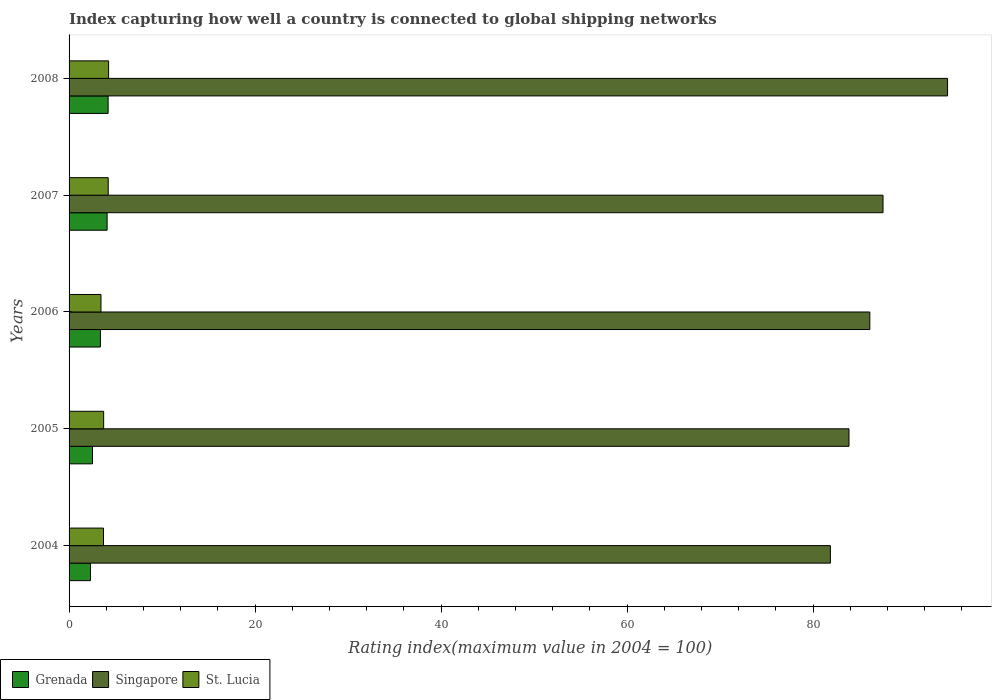How many different coloured bars are there?
Provide a short and direct response. 3. Are the number of bars on each tick of the Y-axis equal?
Keep it short and to the point. Yes. How many bars are there on the 3rd tick from the top?
Offer a terse response. 3. What is the label of the 1st group of bars from the top?
Give a very brief answer. 2008. In how many cases, is the number of bars for a given year not equal to the number of legend labels?
Your answer should be compact. 0. What is the rating index in St. Lucia in 2007?
Give a very brief answer. 4.21. Across all years, what is the maximum rating index in St. Lucia?
Give a very brief answer. 4.25. In which year was the rating index in Grenada minimum?
Ensure brevity in your answer.  2004. What is the total rating index in St. Lucia in the graph?
Your response must be concise. 19.31. What is the difference between the rating index in St. Lucia in 2006 and that in 2007?
Make the answer very short. -0.78. What is the difference between the rating index in St. Lucia in 2006 and the rating index in Singapore in 2005?
Offer a terse response. -80.44. What is the average rating index in Singapore per year?
Your response must be concise. 86.77. In the year 2006, what is the difference between the rating index in St. Lucia and rating index in Grenada?
Offer a terse response. 0.06. In how many years, is the rating index in Singapore greater than 64 ?
Provide a short and direct response. 5. What is the ratio of the rating index in Singapore in 2005 to that in 2008?
Your answer should be very brief. 0.89. Is the rating index in St. Lucia in 2005 less than that in 2007?
Provide a succinct answer. Yes. What is the difference between the highest and the second highest rating index in Singapore?
Provide a short and direct response. 6.94. What is the difference between the highest and the lowest rating index in Grenada?
Ensure brevity in your answer.  1.9. What does the 1st bar from the top in 2006 represents?
Your answer should be very brief. St. Lucia. What does the 3rd bar from the bottom in 2005 represents?
Provide a succinct answer. St. Lucia. Is it the case that in every year, the sum of the rating index in St. Lucia and rating index in Grenada is greater than the rating index in Singapore?
Offer a terse response. No. How many bars are there?
Keep it short and to the point. 15. Are all the bars in the graph horizontal?
Keep it short and to the point. Yes. How many years are there in the graph?
Ensure brevity in your answer.  5. Are the values on the major ticks of X-axis written in scientific E-notation?
Offer a very short reply. No. Does the graph contain any zero values?
Ensure brevity in your answer.  No. Where does the legend appear in the graph?
Ensure brevity in your answer.  Bottom left. How many legend labels are there?
Your response must be concise. 3. What is the title of the graph?
Your response must be concise. Index capturing how well a country is connected to global shipping networks. Does "Colombia" appear as one of the legend labels in the graph?
Your answer should be compact. No. What is the label or title of the X-axis?
Your answer should be very brief. Rating index(maximum value in 2004 = 100). What is the Rating index(maximum value in 2004 = 100) of Singapore in 2004?
Your response must be concise. 81.87. What is the Rating index(maximum value in 2004 = 100) of St. Lucia in 2004?
Your response must be concise. 3.7. What is the Rating index(maximum value in 2004 = 100) of Grenada in 2005?
Keep it short and to the point. 2.52. What is the Rating index(maximum value in 2004 = 100) in Singapore in 2005?
Offer a very short reply. 83.87. What is the Rating index(maximum value in 2004 = 100) of St. Lucia in 2005?
Provide a succinct answer. 3.72. What is the Rating index(maximum value in 2004 = 100) in Grenada in 2006?
Your response must be concise. 3.37. What is the Rating index(maximum value in 2004 = 100) in Singapore in 2006?
Provide a short and direct response. 86.11. What is the Rating index(maximum value in 2004 = 100) of St. Lucia in 2006?
Your answer should be compact. 3.43. What is the Rating index(maximum value in 2004 = 100) of Grenada in 2007?
Offer a very short reply. 4.09. What is the Rating index(maximum value in 2004 = 100) of Singapore in 2007?
Your answer should be very brief. 87.53. What is the Rating index(maximum value in 2004 = 100) in St. Lucia in 2007?
Make the answer very short. 4.21. What is the Rating index(maximum value in 2004 = 100) in Singapore in 2008?
Your response must be concise. 94.47. What is the Rating index(maximum value in 2004 = 100) of St. Lucia in 2008?
Ensure brevity in your answer.  4.25. Across all years, what is the maximum Rating index(maximum value in 2004 = 100) of Singapore?
Keep it short and to the point. 94.47. Across all years, what is the maximum Rating index(maximum value in 2004 = 100) in St. Lucia?
Give a very brief answer. 4.25. Across all years, what is the minimum Rating index(maximum value in 2004 = 100) of Singapore?
Your response must be concise. 81.87. Across all years, what is the minimum Rating index(maximum value in 2004 = 100) in St. Lucia?
Offer a terse response. 3.43. What is the total Rating index(maximum value in 2004 = 100) in Grenada in the graph?
Provide a short and direct response. 16.48. What is the total Rating index(maximum value in 2004 = 100) in Singapore in the graph?
Keep it short and to the point. 433.85. What is the total Rating index(maximum value in 2004 = 100) in St. Lucia in the graph?
Provide a succinct answer. 19.31. What is the difference between the Rating index(maximum value in 2004 = 100) of Grenada in 2004 and that in 2005?
Give a very brief answer. -0.22. What is the difference between the Rating index(maximum value in 2004 = 100) of St. Lucia in 2004 and that in 2005?
Make the answer very short. -0.02. What is the difference between the Rating index(maximum value in 2004 = 100) of Grenada in 2004 and that in 2006?
Offer a terse response. -1.07. What is the difference between the Rating index(maximum value in 2004 = 100) of Singapore in 2004 and that in 2006?
Provide a succinct answer. -4.24. What is the difference between the Rating index(maximum value in 2004 = 100) of St. Lucia in 2004 and that in 2006?
Ensure brevity in your answer.  0.27. What is the difference between the Rating index(maximum value in 2004 = 100) in Grenada in 2004 and that in 2007?
Keep it short and to the point. -1.79. What is the difference between the Rating index(maximum value in 2004 = 100) in Singapore in 2004 and that in 2007?
Provide a short and direct response. -5.66. What is the difference between the Rating index(maximum value in 2004 = 100) in St. Lucia in 2004 and that in 2007?
Your answer should be compact. -0.51. What is the difference between the Rating index(maximum value in 2004 = 100) in Singapore in 2004 and that in 2008?
Keep it short and to the point. -12.6. What is the difference between the Rating index(maximum value in 2004 = 100) of St. Lucia in 2004 and that in 2008?
Provide a succinct answer. -0.55. What is the difference between the Rating index(maximum value in 2004 = 100) in Grenada in 2005 and that in 2006?
Your response must be concise. -0.85. What is the difference between the Rating index(maximum value in 2004 = 100) of Singapore in 2005 and that in 2006?
Ensure brevity in your answer.  -2.24. What is the difference between the Rating index(maximum value in 2004 = 100) of St. Lucia in 2005 and that in 2006?
Offer a very short reply. 0.29. What is the difference between the Rating index(maximum value in 2004 = 100) in Grenada in 2005 and that in 2007?
Make the answer very short. -1.57. What is the difference between the Rating index(maximum value in 2004 = 100) in Singapore in 2005 and that in 2007?
Ensure brevity in your answer.  -3.66. What is the difference between the Rating index(maximum value in 2004 = 100) in St. Lucia in 2005 and that in 2007?
Provide a succinct answer. -0.49. What is the difference between the Rating index(maximum value in 2004 = 100) in Grenada in 2005 and that in 2008?
Your answer should be very brief. -1.68. What is the difference between the Rating index(maximum value in 2004 = 100) of St. Lucia in 2005 and that in 2008?
Offer a very short reply. -0.53. What is the difference between the Rating index(maximum value in 2004 = 100) of Grenada in 2006 and that in 2007?
Make the answer very short. -0.72. What is the difference between the Rating index(maximum value in 2004 = 100) in Singapore in 2006 and that in 2007?
Ensure brevity in your answer.  -1.42. What is the difference between the Rating index(maximum value in 2004 = 100) of St. Lucia in 2006 and that in 2007?
Your response must be concise. -0.78. What is the difference between the Rating index(maximum value in 2004 = 100) of Grenada in 2006 and that in 2008?
Ensure brevity in your answer.  -0.83. What is the difference between the Rating index(maximum value in 2004 = 100) of Singapore in 2006 and that in 2008?
Offer a very short reply. -8.36. What is the difference between the Rating index(maximum value in 2004 = 100) in St. Lucia in 2006 and that in 2008?
Your answer should be very brief. -0.82. What is the difference between the Rating index(maximum value in 2004 = 100) of Grenada in 2007 and that in 2008?
Offer a very short reply. -0.11. What is the difference between the Rating index(maximum value in 2004 = 100) of Singapore in 2007 and that in 2008?
Offer a very short reply. -6.94. What is the difference between the Rating index(maximum value in 2004 = 100) of St. Lucia in 2007 and that in 2008?
Offer a very short reply. -0.04. What is the difference between the Rating index(maximum value in 2004 = 100) of Grenada in 2004 and the Rating index(maximum value in 2004 = 100) of Singapore in 2005?
Your answer should be compact. -81.57. What is the difference between the Rating index(maximum value in 2004 = 100) in Grenada in 2004 and the Rating index(maximum value in 2004 = 100) in St. Lucia in 2005?
Offer a very short reply. -1.42. What is the difference between the Rating index(maximum value in 2004 = 100) of Singapore in 2004 and the Rating index(maximum value in 2004 = 100) of St. Lucia in 2005?
Offer a very short reply. 78.15. What is the difference between the Rating index(maximum value in 2004 = 100) of Grenada in 2004 and the Rating index(maximum value in 2004 = 100) of Singapore in 2006?
Provide a short and direct response. -83.81. What is the difference between the Rating index(maximum value in 2004 = 100) of Grenada in 2004 and the Rating index(maximum value in 2004 = 100) of St. Lucia in 2006?
Keep it short and to the point. -1.13. What is the difference between the Rating index(maximum value in 2004 = 100) in Singapore in 2004 and the Rating index(maximum value in 2004 = 100) in St. Lucia in 2006?
Keep it short and to the point. 78.44. What is the difference between the Rating index(maximum value in 2004 = 100) in Grenada in 2004 and the Rating index(maximum value in 2004 = 100) in Singapore in 2007?
Provide a succinct answer. -85.23. What is the difference between the Rating index(maximum value in 2004 = 100) in Grenada in 2004 and the Rating index(maximum value in 2004 = 100) in St. Lucia in 2007?
Give a very brief answer. -1.91. What is the difference between the Rating index(maximum value in 2004 = 100) of Singapore in 2004 and the Rating index(maximum value in 2004 = 100) of St. Lucia in 2007?
Provide a short and direct response. 77.66. What is the difference between the Rating index(maximum value in 2004 = 100) of Grenada in 2004 and the Rating index(maximum value in 2004 = 100) of Singapore in 2008?
Offer a terse response. -92.17. What is the difference between the Rating index(maximum value in 2004 = 100) of Grenada in 2004 and the Rating index(maximum value in 2004 = 100) of St. Lucia in 2008?
Give a very brief answer. -1.95. What is the difference between the Rating index(maximum value in 2004 = 100) of Singapore in 2004 and the Rating index(maximum value in 2004 = 100) of St. Lucia in 2008?
Ensure brevity in your answer.  77.62. What is the difference between the Rating index(maximum value in 2004 = 100) of Grenada in 2005 and the Rating index(maximum value in 2004 = 100) of Singapore in 2006?
Make the answer very short. -83.59. What is the difference between the Rating index(maximum value in 2004 = 100) in Grenada in 2005 and the Rating index(maximum value in 2004 = 100) in St. Lucia in 2006?
Provide a succinct answer. -0.91. What is the difference between the Rating index(maximum value in 2004 = 100) in Singapore in 2005 and the Rating index(maximum value in 2004 = 100) in St. Lucia in 2006?
Give a very brief answer. 80.44. What is the difference between the Rating index(maximum value in 2004 = 100) in Grenada in 2005 and the Rating index(maximum value in 2004 = 100) in Singapore in 2007?
Your answer should be compact. -85.01. What is the difference between the Rating index(maximum value in 2004 = 100) in Grenada in 2005 and the Rating index(maximum value in 2004 = 100) in St. Lucia in 2007?
Offer a terse response. -1.69. What is the difference between the Rating index(maximum value in 2004 = 100) in Singapore in 2005 and the Rating index(maximum value in 2004 = 100) in St. Lucia in 2007?
Provide a short and direct response. 79.66. What is the difference between the Rating index(maximum value in 2004 = 100) of Grenada in 2005 and the Rating index(maximum value in 2004 = 100) of Singapore in 2008?
Make the answer very short. -91.95. What is the difference between the Rating index(maximum value in 2004 = 100) in Grenada in 2005 and the Rating index(maximum value in 2004 = 100) in St. Lucia in 2008?
Make the answer very short. -1.73. What is the difference between the Rating index(maximum value in 2004 = 100) in Singapore in 2005 and the Rating index(maximum value in 2004 = 100) in St. Lucia in 2008?
Keep it short and to the point. 79.62. What is the difference between the Rating index(maximum value in 2004 = 100) in Grenada in 2006 and the Rating index(maximum value in 2004 = 100) in Singapore in 2007?
Offer a very short reply. -84.16. What is the difference between the Rating index(maximum value in 2004 = 100) in Grenada in 2006 and the Rating index(maximum value in 2004 = 100) in St. Lucia in 2007?
Offer a terse response. -0.84. What is the difference between the Rating index(maximum value in 2004 = 100) in Singapore in 2006 and the Rating index(maximum value in 2004 = 100) in St. Lucia in 2007?
Provide a succinct answer. 81.9. What is the difference between the Rating index(maximum value in 2004 = 100) of Grenada in 2006 and the Rating index(maximum value in 2004 = 100) of Singapore in 2008?
Keep it short and to the point. -91.1. What is the difference between the Rating index(maximum value in 2004 = 100) in Grenada in 2006 and the Rating index(maximum value in 2004 = 100) in St. Lucia in 2008?
Offer a very short reply. -0.88. What is the difference between the Rating index(maximum value in 2004 = 100) of Singapore in 2006 and the Rating index(maximum value in 2004 = 100) of St. Lucia in 2008?
Make the answer very short. 81.86. What is the difference between the Rating index(maximum value in 2004 = 100) in Grenada in 2007 and the Rating index(maximum value in 2004 = 100) in Singapore in 2008?
Your answer should be very brief. -90.38. What is the difference between the Rating index(maximum value in 2004 = 100) in Grenada in 2007 and the Rating index(maximum value in 2004 = 100) in St. Lucia in 2008?
Give a very brief answer. -0.16. What is the difference between the Rating index(maximum value in 2004 = 100) of Singapore in 2007 and the Rating index(maximum value in 2004 = 100) of St. Lucia in 2008?
Ensure brevity in your answer.  83.28. What is the average Rating index(maximum value in 2004 = 100) of Grenada per year?
Your answer should be very brief. 3.3. What is the average Rating index(maximum value in 2004 = 100) of Singapore per year?
Offer a very short reply. 86.77. What is the average Rating index(maximum value in 2004 = 100) in St. Lucia per year?
Provide a short and direct response. 3.86. In the year 2004, what is the difference between the Rating index(maximum value in 2004 = 100) in Grenada and Rating index(maximum value in 2004 = 100) in Singapore?
Give a very brief answer. -79.57. In the year 2004, what is the difference between the Rating index(maximum value in 2004 = 100) of Singapore and Rating index(maximum value in 2004 = 100) of St. Lucia?
Your answer should be compact. 78.17. In the year 2005, what is the difference between the Rating index(maximum value in 2004 = 100) in Grenada and Rating index(maximum value in 2004 = 100) in Singapore?
Ensure brevity in your answer.  -81.35. In the year 2005, what is the difference between the Rating index(maximum value in 2004 = 100) in Singapore and Rating index(maximum value in 2004 = 100) in St. Lucia?
Your answer should be compact. 80.15. In the year 2006, what is the difference between the Rating index(maximum value in 2004 = 100) in Grenada and Rating index(maximum value in 2004 = 100) in Singapore?
Ensure brevity in your answer.  -82.74. In the year 2006, what is the difference between the Rating index(maximum value in 2004 = 100) of Grenada and Rating index(maximum value in 2004 = 100) of St. Lucia?
Your response must be concise. -0.06. In the year 2006, what is the difference between the Rating index(maximum value in 2004 = 100) in Singapore and Rating index(maximum value in 2004 = 100) in St. Lucia?
Offer a terse response. 82.68. In the year 2007, what is the difference between the Rating index(maximum value in 2004 = 100) of Grenada and Rating index(maximum value in 2004 = 100) of Singapore?
Give a very brief answer. -83.44. In the year 2007, what is the difference between the Rating index(maximum value in 2004 = 100) in Grenada and Rating index(maximum value in 2004 = 100) in St. Lucia?
Give a very brief answer. -0.12. In the year 2007, what is the difference between the Rating index(maximum value in 2004 = 100) of Singapore and Rating index(maximum value in 2004 = 100) of St. Lucia?
Offer a terse response. 83.32. In the year 2008, what is the difference between the Rating index(maximum value in 2004 = 100) in Grenada and Rating index(maximum value in 2004 = 100) in Singapore?
Give a very brief answer. -90.27. In the year 2008, what is the difference between the Rating index(maximum value in 2004 = 100) in Singapore and Rating index(maximum value in 2004 = 100) in St. Lucia?
Give a very brief answer. 90.22. What is the ratio of the Rating index(maximum value in 2004 = 100) in Grenada in 2004 to that in 2005?
Make the answer very short. 0.91. What is the ratio of the Rating index(maximum value in 2004 = 100) in Singapore in 2004 to that in 2005?
Provide a short and direct response. 0.98. What is the ratio of the Rating index(maximum value in 2004 = 100) in Grenada in 2004 to that in 2006?
Your answer should be compact. 0.68. What is the ratio of the Rating index(maximum value in 2004 = 100) in Singapore in 2004 to that in 2006?
Offer a very short reply. 0.95. What is the ratio of the Rating index(maximum value in 2004 = 100) of St. Lucia in 2004 to that in 2006?
Keep it short and to the point. 1.08. What is the ratio of the Rating index(maximum value in 2004 = 100) of Grenada in 2004 to that in 2007?
Your answer should be compact. 0.56. What is the ratio of the Rating index(maximum value in 2004 = 100) of Singapore in 2004 to that in 2007?
Your answer should be compact. 0.94. What is the ratio of the Rating index(maximum value in 2004 = 100) in St. Lucia in 2004 to that in 2007?
Keep it short and to the point. 0.88. What is the ratio of the Rating index(maximum value in 2004 = 100) in Grenada in 2004 to that in 2008?
Provide a succinct answer. 0.55. What is the ratio of the Rating index(maximum value in 2004 = 100) in Singapore in 2004 to that in 2008?
Provide a succinct answer. 0.87. What is the ratio of the Rating index(maximum value in 2004 = 100) in St. Lucia in 2004 to that in 2008?
Your answer should be compact. 0.87. What is the ratio of the Rating index(maximum value in 2004 = 100) of Grenada in 2005 to that in 2006?
Give a very brief answer. 0.75. What is the ratio of the Rating index(maximum value in 2004 = 100) in St. Lucia in 2005 to that in 2006?
Make the answer very short. 1.08. What is the ratio of the Rating index(maximum value in 2004 = 100) in Grenada in 2005 to that in 2007?
Your answer should be compact. 0.62. What is the ratio of the Rating index(maximum value in 2004 = 100) in Singapore in 2005 to that in 2007?
Your answer should be compact. 0.96. What is the ratio of the Rating index(maximum value in 2004 = 100) in St. Lucia in 2005 to that in 2007?
Your response must be concise. 0.88. What is the ratio of the Rating index(maximum value in 2004 = 100) of Singapore in 2005 to that in 2008?
Provide a succinct answer. 0.89. What is the ratio of the Rating index(maximum value in 2004 = 100) of St. Lucia in 2005 to that in 2008?
Give a very brief answer. 0.88. What is the ratio of the Rating index(maximum value in 2004 = 100) in Grenada in 2006 to that in 2007?
Offer a very short reply. 0.82. What is the ratio of the Rating index(maximum value in 2004 = 100) of Singapore in 2006 to that in 2007?
Give a very brief answer. 0.98. What is the ratio of the Rating index(maximum value in 2004 = 100) of St. Lucia in 2006 to that in 2007?
Make the answer very short. 0.81. What is the ratio of the Rating index(maximum value in 2004 = 100) in Grenada in 2006 to that in 2008?
Ensure brevity in your answer.  0.8. What is the ratio of the Rating index(maximum value in 2004 = 100) of Singapore in 2006 to that in 2008?
Provide a succinct answer. 0.91. What is the ratio of the Rating index(maximum value in 2004 = 100) of St. Lucia in 2006 to that in 2008?
Provide a short and direct response. 0.81. What is the ratio of the Rating index(maximum value in 2004 = 100) of Grenada in 2007 to that in 2008?
Your answer should be very brief. 0.97. What is the ratio of the Rating index(maximum value in 2004 = 100) in Singapore in 2007 to that in 2008?
Your answer should be compact. 0.93. What is the ratio of the Rating index(maximum value in 2004 = 100) in St. Lucia in 2007 to that in 2008?
Keep it short and to the point. 0.99. What is the difference between the highest and the second highest Rating index(maximum value in 2004 = 100) in Grenada?
Offer a very short reply. 0.11. What is the difference between the highest and the second highest Rating index(maximum value in 2004 = 100) of Singapore?
Provide a succinct answer. 6.94. What is the difference between the highest and the second highest Rating index(maximum value in 2004 = 100) in St. Lucia?
Provide a succinct answer. 0.04. What is the difference between the highest and the lowest Rating index(maximum value in 2004 = 100) of Grenada?
Offer a terse response. 1.9. What is the difference between the highest and the lowest Rating index(maximum value in 2004 = 100) of Singapore?
Your answer should be very brief. 12.6. What is the difference between the highest and the lowest Rating index(maximum value in 2004 = 100) in St. Lucia?
Keep it short and to the point. 0.82. 